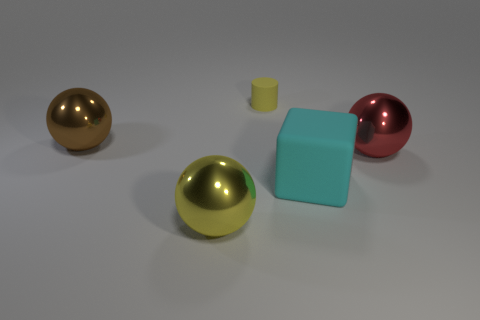Subtract all yellow metal balls. How many balls are left? 2 Add 4 cyan matte balls. How many objects exist? 9 Subtract 1 cubes. How many cubes are left? 0 Subtract all red spheres. How many spheres are left? 2 Subtract all green cylinders. How many purple cubes are left? 0 Subtract all metallic things. Subtract all cyan cubes. How many objects are left? 1 Add 2 matte blocks. How many matte blocks are left? 3 Add 3 red metal balls. How many red metal balls exist? 4 Subtract 0 blue balls. How many objects are left? 5 Subtract all balls. How many objects are left? 2 